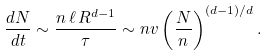<formula> <loc_0><loc_0><loc_500><loc_500>\frac { d N } { d t } \sim \frac { n \, \ell \, R ^ { d - 1 } } { \tau } \sim n v \left ( \frac { N } { n } \right ) ^ { ( d - 1 ) / d } .</formula> 